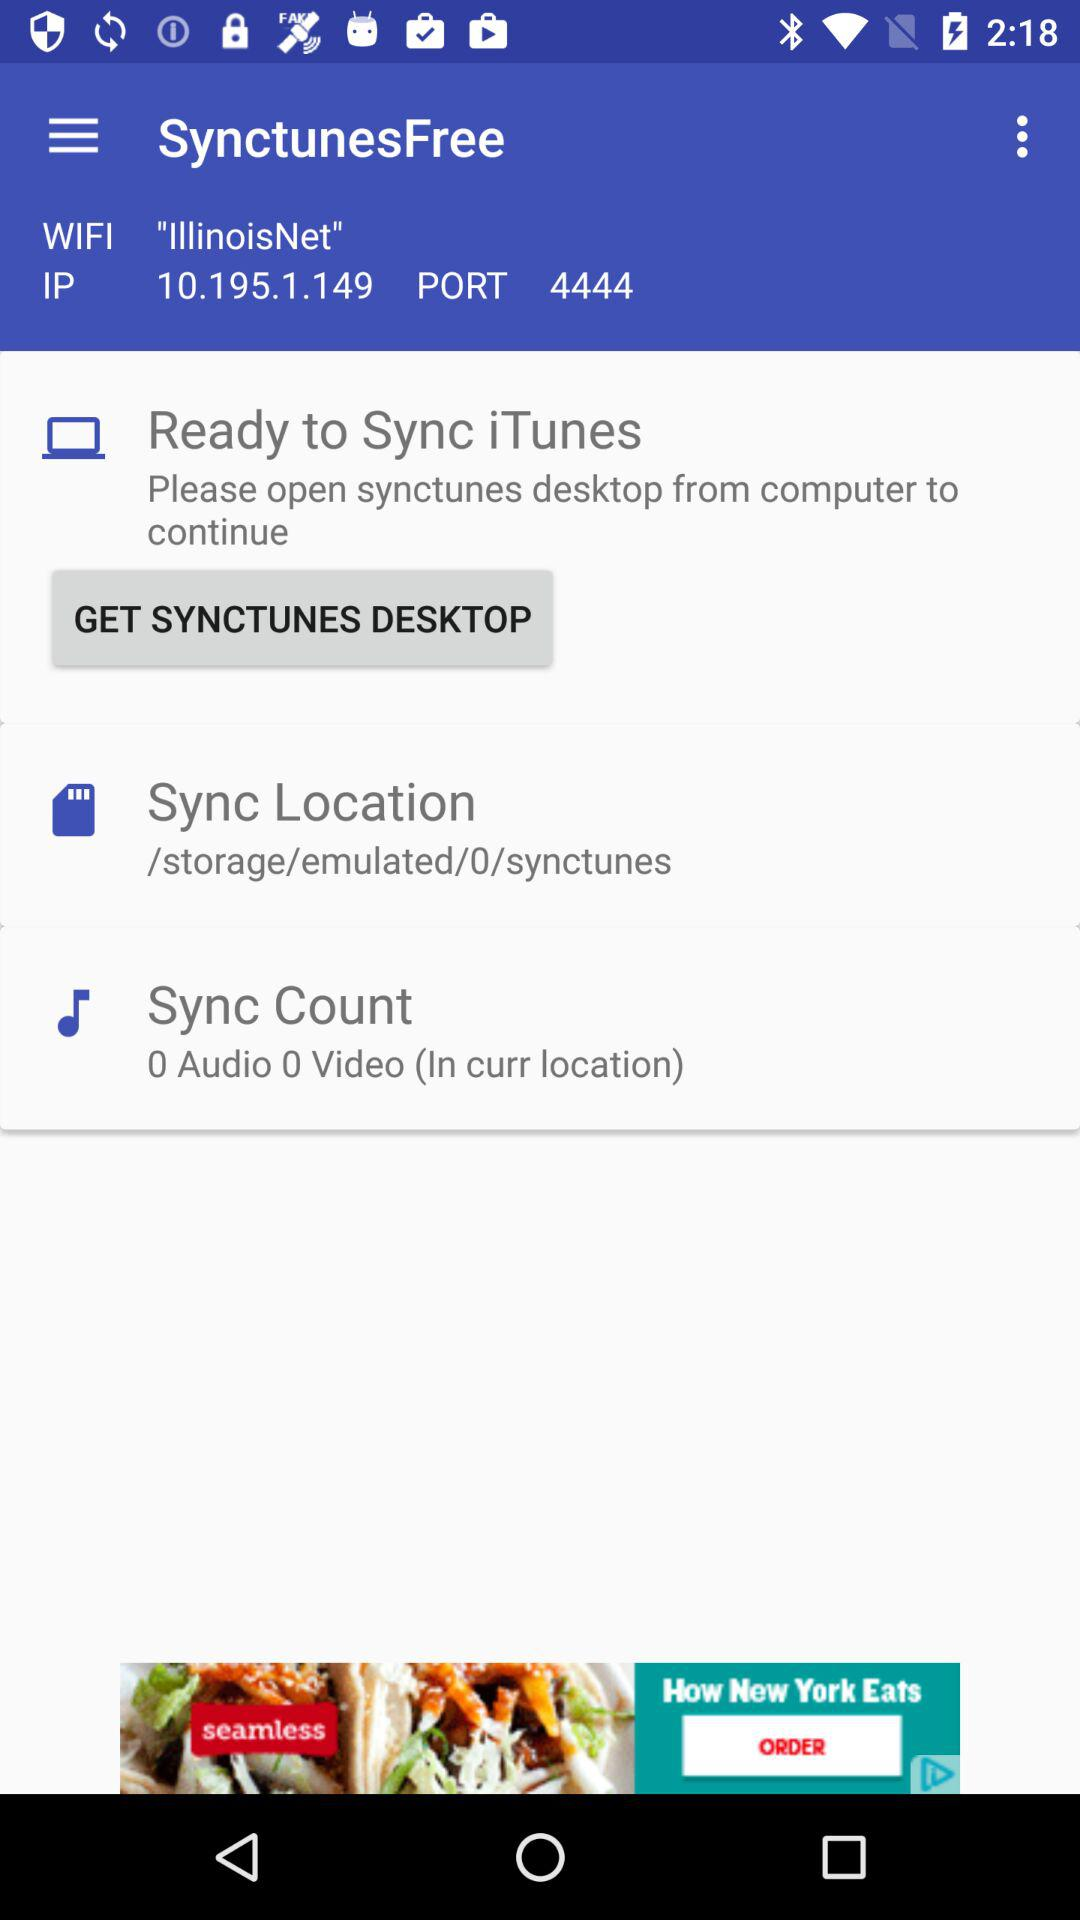What is the name of the Wi-Fi network? The name of the Wi-Fi network is "IllinoisNet". 